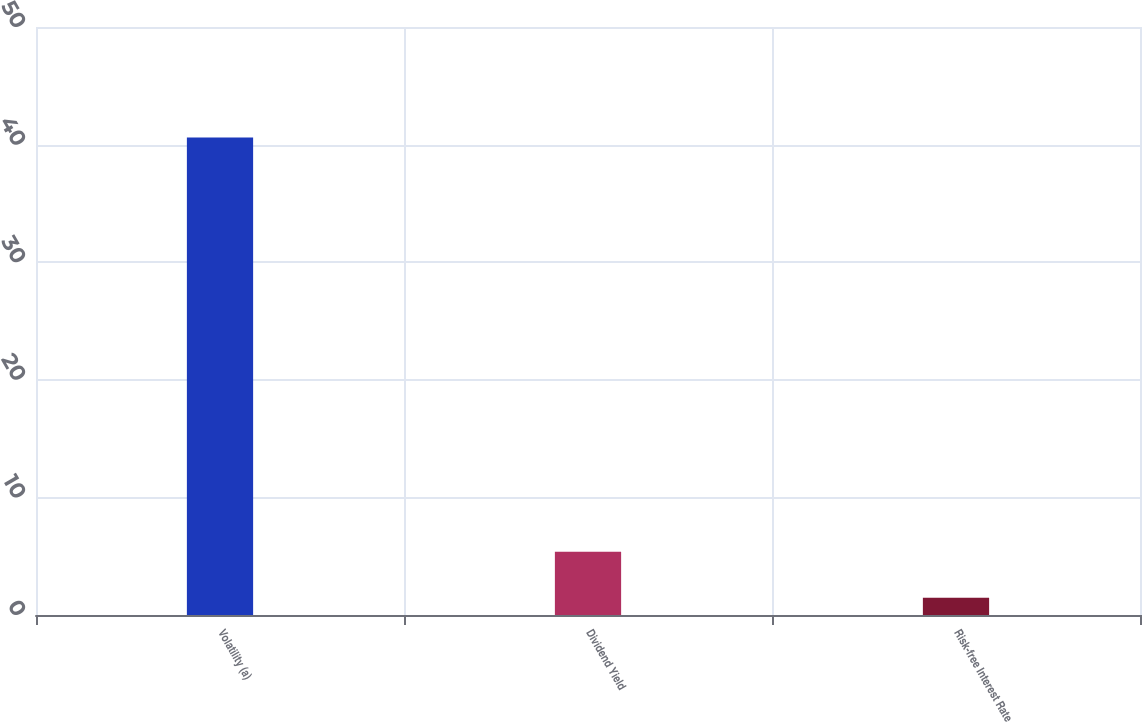<chart> <loc_0><loc_0><loc_500><loc_500><bar_chart><fcel>Volatility (a)<fcel>Dividend Yield<fcel>Risk-free Interest Rate<nl><fcel>40.6<fcel>5.38<fcel>1.47<nl></chart> 